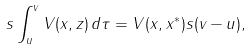Convert formula to latex. <formula><loc_0><loc_0><loc_500><loc_500>s \int _ { u } ^ { v } V ( x , z ) \, d \tau = V ( x , x ^ { * } ) s ( v - u ) ,</formula> 